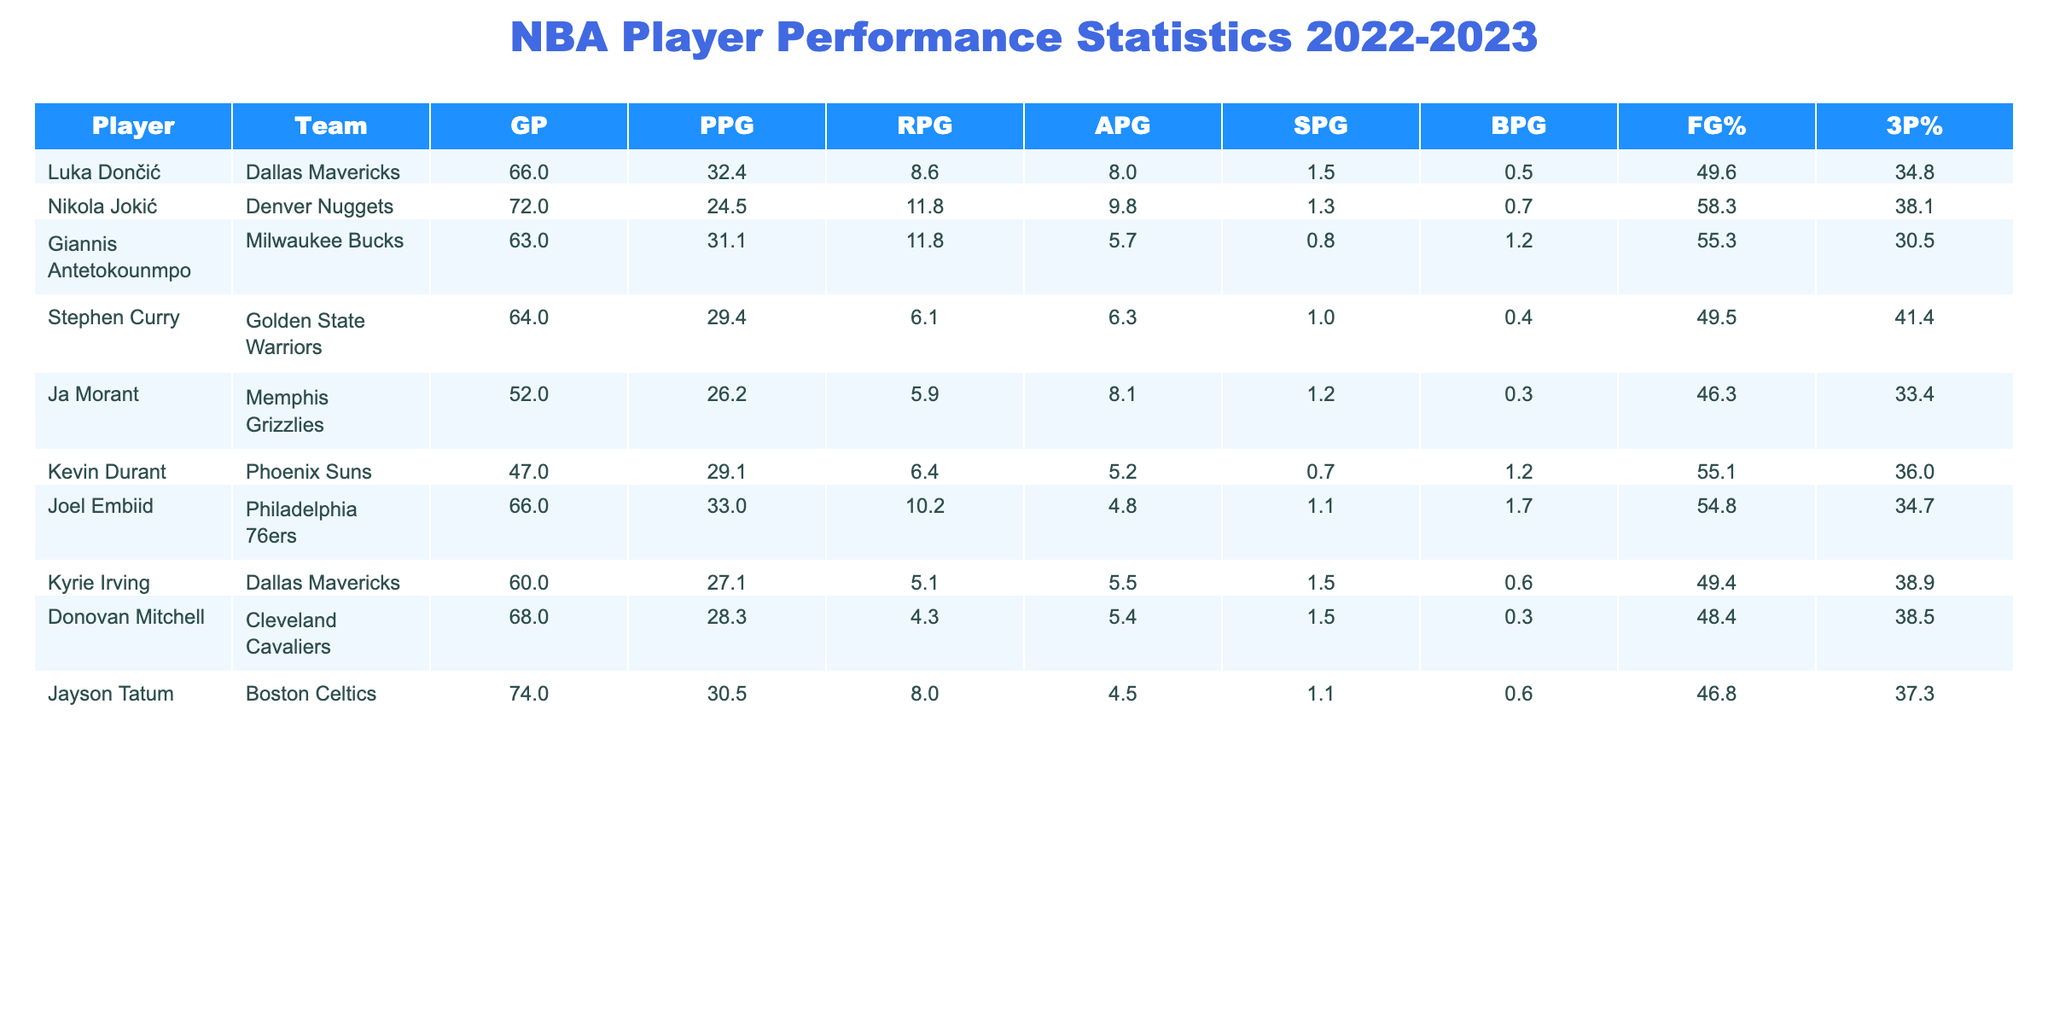What is Luka Dončić's points per game? Luka Dončić has a "Points per Game" value of 32.4 listed in the table.
Answer: 32.4 Who has the highest rebounds per game this season? By looking at the "Rebounds per Game" column, both Nikola Jokić and Giannis Antetokounmpo have a value of 11.8, which is the highest in the table.
Answer: Nikola Jokić and Giannis Antetokounmpo Is Stephen Curry's three-point percentage higher than Luka Dončić's? Stephen Curry's three-point percentage is 41.4, while Luka Dončić's is 34.8. Since 41.4 is greater than 34.8, the answer is yes.
Answer: Yes What is the average points per game for players who played more than 60 games? The players who played more than 60 games are Luka Dončić, Nikola Jokić, Giannis Antetokounmpo, Joel Embiid, Kyrie Irving, Donovan Mitchell, and Jayson Tatum. Their points per game values are 32.4, 24.5, 31.1, 33.0, 27.1, 28.3, and 30.5 respectively. Summing these values gives 207.9. There are 7 players, so the average is 207.9 / 7 = 29.7.
Answer: 29.7 Which player has the lowest field goal percentage? By scanning the "Field Goal Percentage" column, Ja Morant has the lowest value at 46.3.
Answer: Ja Morant Did any player average more than 30 points per game? Looking at the "Points per Game" column, Luka Dončić (32.4) and Joel Embiid (33.0) both have averages above 30. Therefore, the answer is yes.
Answer: Yes What is the total number of assists per game among players from Dallas Mavericks? The players from Dallas Mavericks are Luka Dončić and Kyrie Irving. Their assists per game averages are 8.0 and 5.5 respectively, which sum to 13.5.
Answer: 13.5 Which player blocked the most shots per game? By checking the "Blocks per Game" column, Joel Embiid has the highest value with 1.7 blocks per game.
Answer: Joel Embiid 